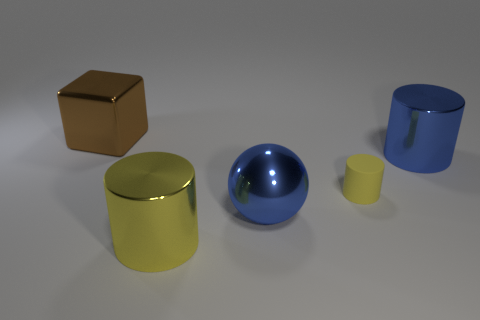Subtract all large metallic cylinders. How many cylinders are left? 1 Add 2 big blue shiny objects. How many objects exist? 7 Subtract all spheres. How many objects are left? 4 Add 2 small matte cylinders. How many small matte cylinders exist? 3 Subtract 0 green cylinders. How many objects are left? 5 Subtract all big spheres. Subtract all blue things. How many objects are left? 2 Add 4 small yellow matte cylinders. How many small yellow matte cylinders are left? 5 